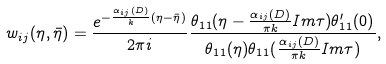Convert formula to latex. <formula><loc_0><loc_0><loc_500><loc_500>w _ { i j } ( \eta , \bar { \eta } ) = \frac { e ^ { - \frac { \alpha _ { i j } ( D ) } { k } ( \eta - \bar { \eta } ) } } { 2 \pi i } \frac { \theta _ { 1 1 } ( \eta - \frac { \alpha _ { i j } ( D ) } { \pi k } I m \tau ) \theta ^ { \prime } _ { 1 1 } ( 0 ) } { \theta _ { 1 1 } ( \eta ) \theta _ { 1 1 } ( \frac { \alpha _ { i j } ( D ) } { \pi k } I m \tau ) } ,</formula> 